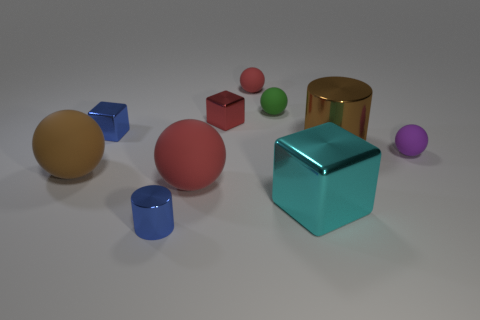How many big objects are right of the large metallic cylinder?
Your response must be concise. 0. Do the small cube on the left side of the tiny red shiny block and the small matte sphere in front of the red metallic object have the same color?
Keep it short and to the point. No. What color is the other large metal thing that is the same shape as the red shiny object?
Provide a short and direct response. Cyan. Is there any other thing that is the same shape as the large brown matte thing?
Your answer should be compact. Yes. Is the shape of the small blue thing that is behind the small metal cylinder the same as the green object that is behind the purple object?
Provide a succinct answer. No. Do the green rubber ball and the red sphere that is in front of the green thing have the same size?
Make the answer very short. No. Is the number of small red rubber spheres greater than the number of red matte balls?
Ensure brevity in your answer.  No. Does the large sphere that is to the right of the large brown matte object have the same material as the cylinder that is to the right of the small red matte thing?
Your answer should be very brief. No. What is the material of the brown cylinder?
Provide a short and direct response. Metal. Is the number of red balls that are left of the tiny red matte thing greater than the number of tiny purple shiny objects?
Provide a succinct answer. Yes. 